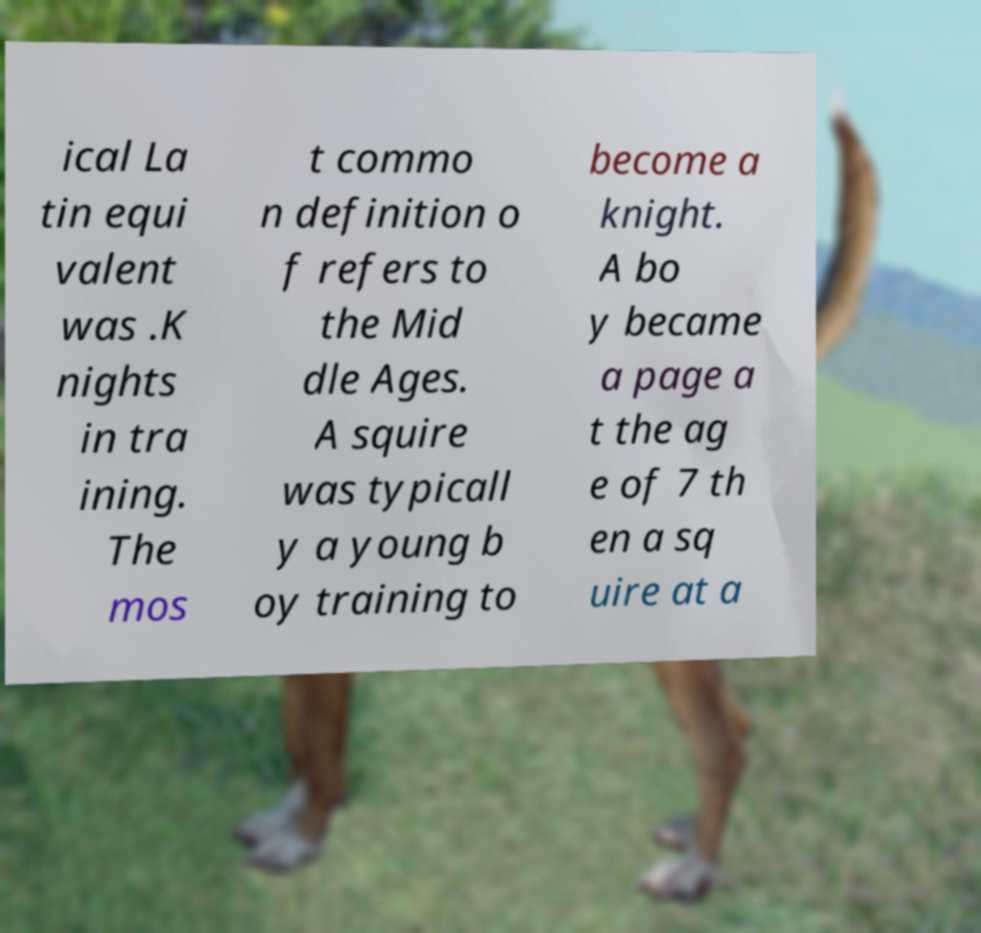Can you read and provide the text displayed in the image?This photo seems to have some interesting text. Can you extract and type it out for me? ical La tin equi valent was .K nights in tra ining. The mos t commo n definition o f refers to the Mid dle Ages. A squire was typicall y a young b oy training to become a knight. A bo y became a page a t the ag e of 7 th en a sq uire at a 